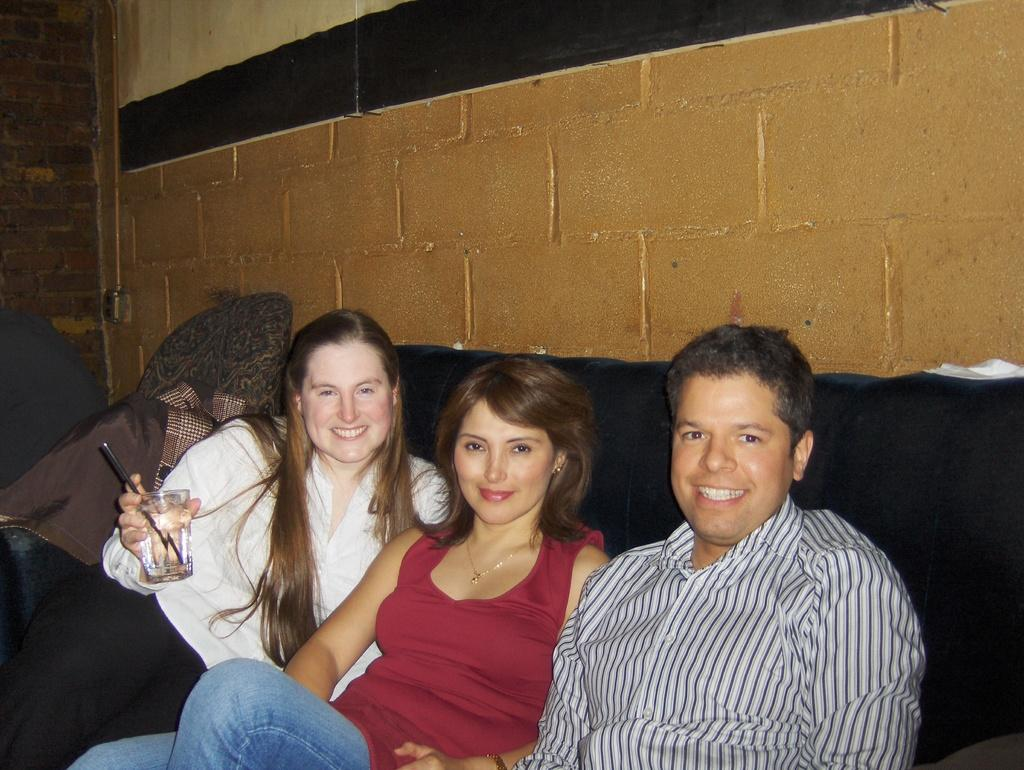What are the people in the image doing? The people in the image are sitting on a sofa. What is the facial expression of the people? The people are smiling. What is the woman holding in the image? The woman is holding a glass. What can be seen behind the woman? There is cloth visible behind the woman. What type of structure is present in the image? There is a wall in the image. What type of wound can be seen on the man's arm in the image? There is no wound visible on the man's arm in the image. What type of glue is being used to attach the jeans to the wall in the image? There are no jeans or glue present in the image. 